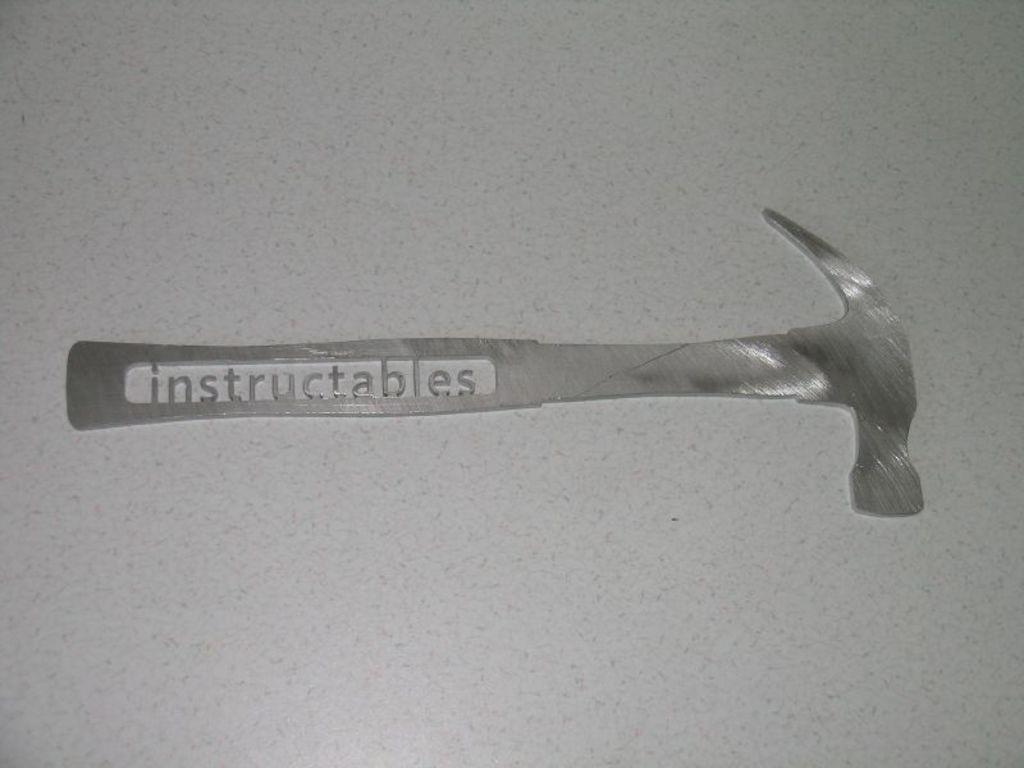What object is depicted in the mold in the image? There is a mold of a hammer in the image. What else can be seen in the image besides the mold? There is writing in the image. What type of advice does the brother give to the lawyer in the image? There is no brother or lawyer present in the image; it only features a mold of a hammer and writing. 